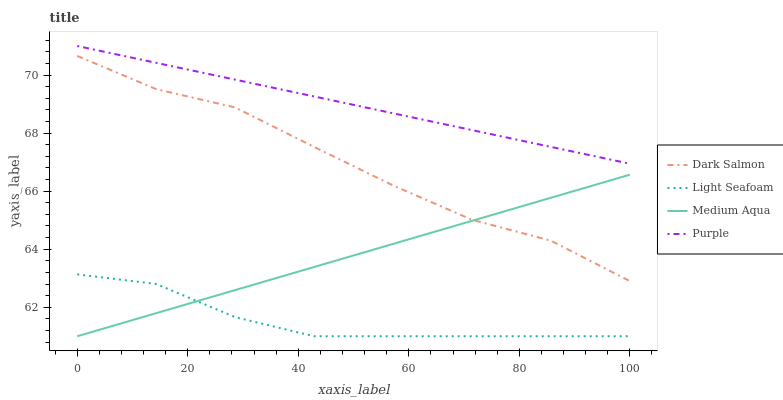Does Light Seafoam have the minimum area under the curve?
Answer yes or no. Yes. Does Purple have the maximum area under the curve?
Answer yes or no. Yes. Does Medium Aqua have the minimum area under the curve?
Answer yes or no. No. Does Medium Aqua have the maximum area under the curve?
Answer yes or no. No. Is Medium Aqua the smoothest?
Answer yes or no. Yes. Is Dark Salmon the roughest?
Answer yes or no. Yes. Is Light Seafoam the smoothest?
Answer yes or no. No. Is Light Seafoam the roughest?
Answer yes or no. No. Does Dark Salmon have the lowest value?
Answer yes or no. No. Does Purple have the highest value?
Answer yes or no. Yes. Does Medium Aqua have the highest value?
Answer yes or no. No. Is Light Seafoam less than Dark Salmon?
Answer yes or no. Yes. Is Purple greater than Light Seafoam?
Answer yes or no. Yes. Does Light Seafoam intersect Medium Aqua?
Answer yes or no. Yes. Is Light Seafoam less than Medium Aqua?
Answer yes or no. No. Is Light Seafoam greater than Medium Aqua?
Answer yes or no. No. Does Light Seafoam intersect Dark Salmon?
Answer yes or no. No. 